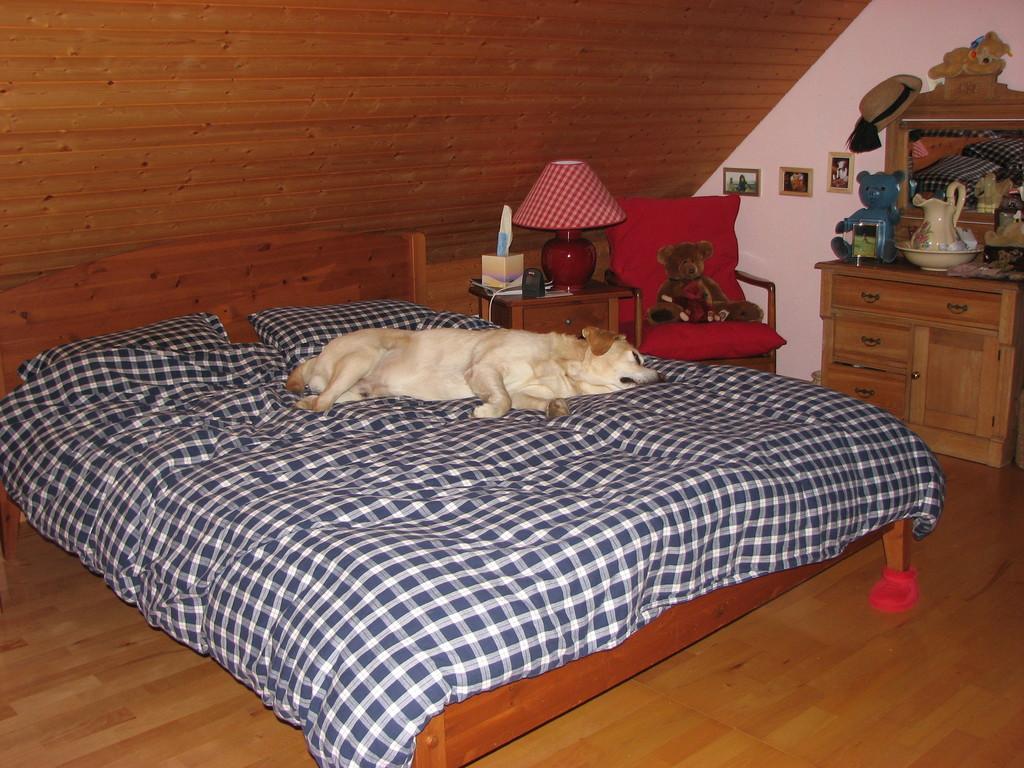Please provide a concise description of this image. Here is a picture where we have a bed and two pillows and a dog on the bed. Beside the bed we have a table on which we have a lamp and also the chair on which there is a doll and on the other side we have a desk on which we have some things placed. 